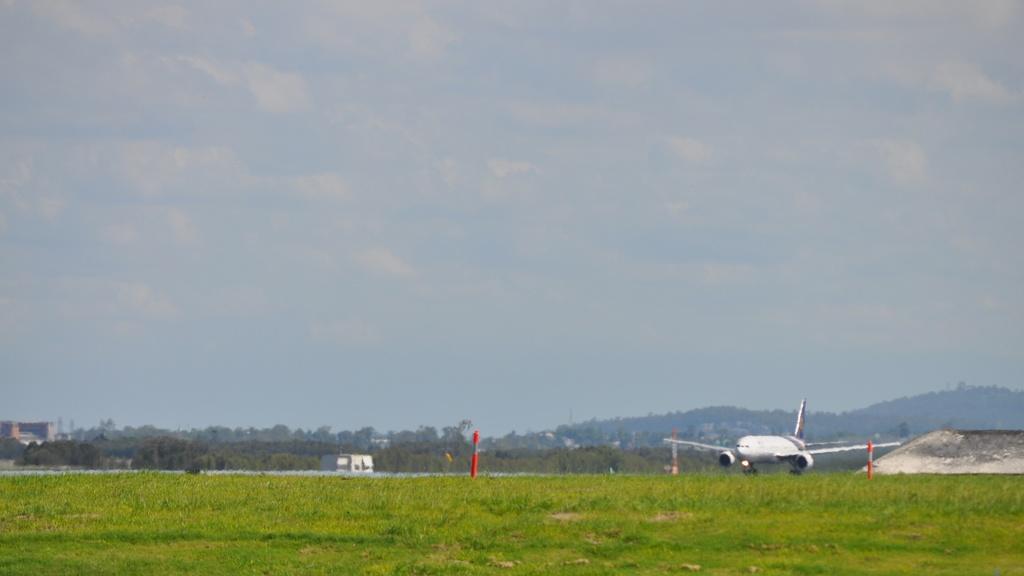In one or two sentences, can you explain what this image depicts? In this image we can see an airplane flying, there are some trees, poles, grass and buildings, in the background we can see the sky with clouds. 